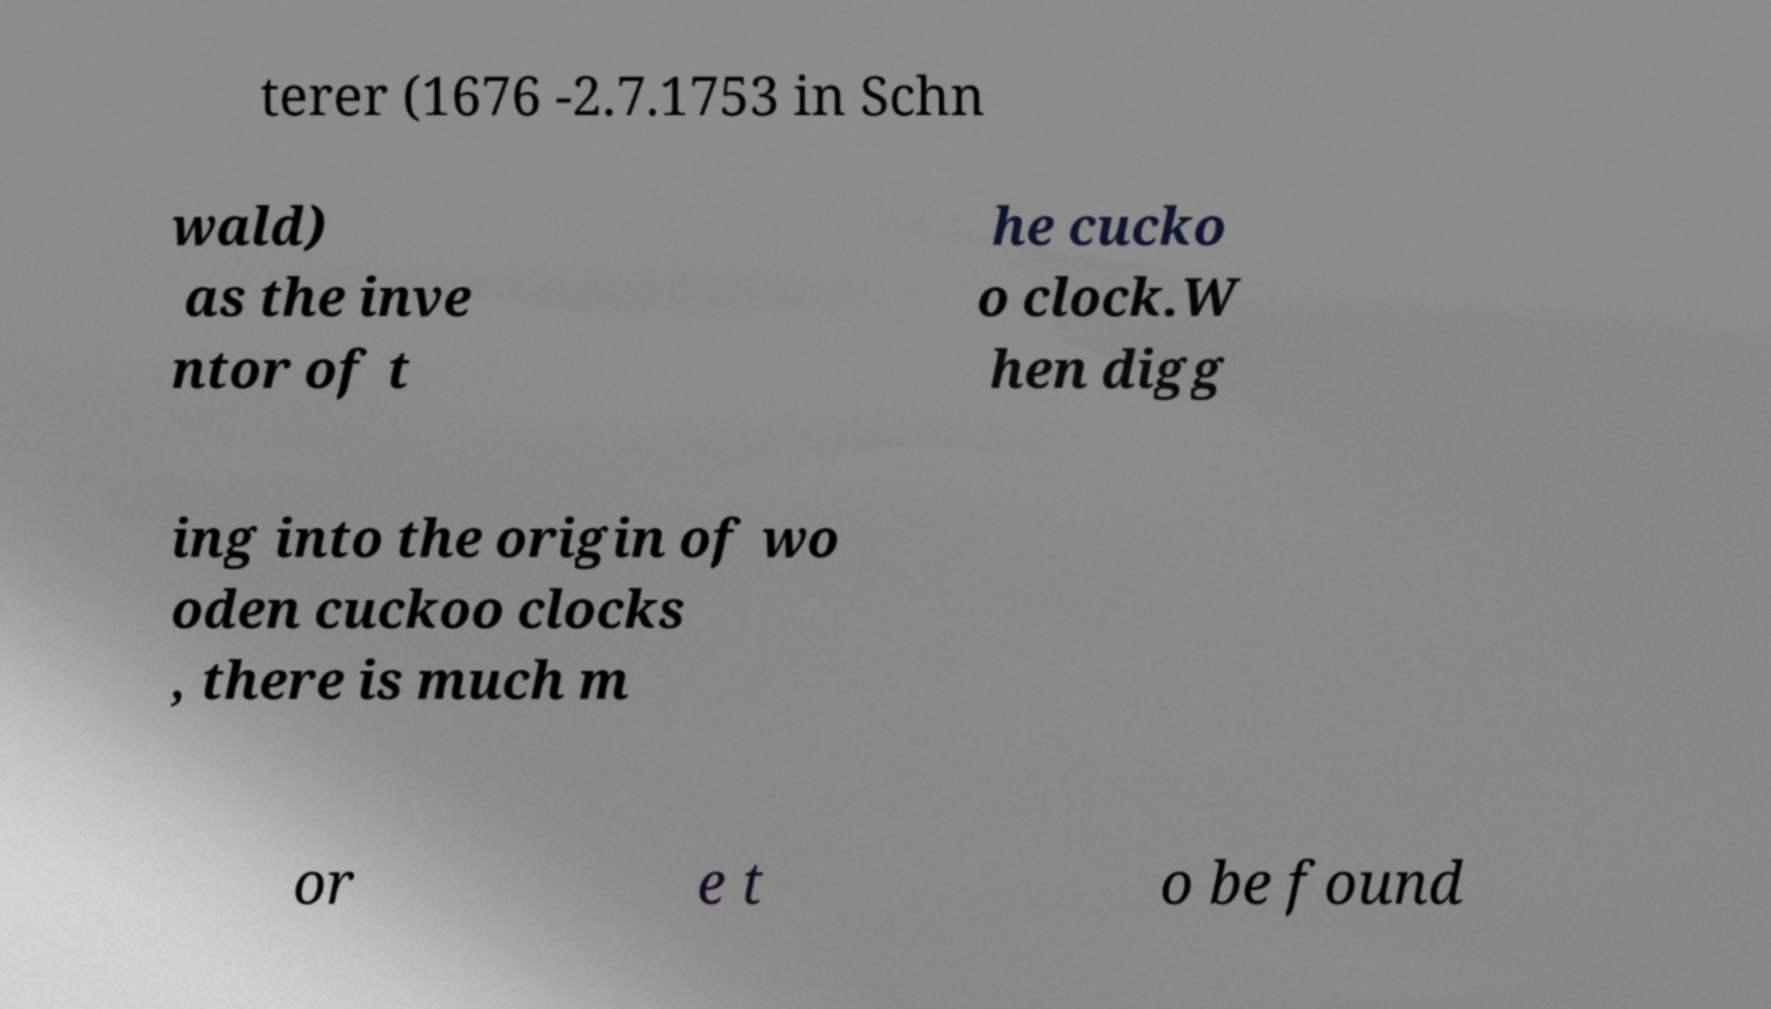Please identify and transcribe the text found in this image. terer (1676 -2.7.1753 in Schn wald) as the inve ntor of t he cucko o clock.W hen digg ing into the origin of wo oden cuckoo clocks , there is much m or e t o be found 